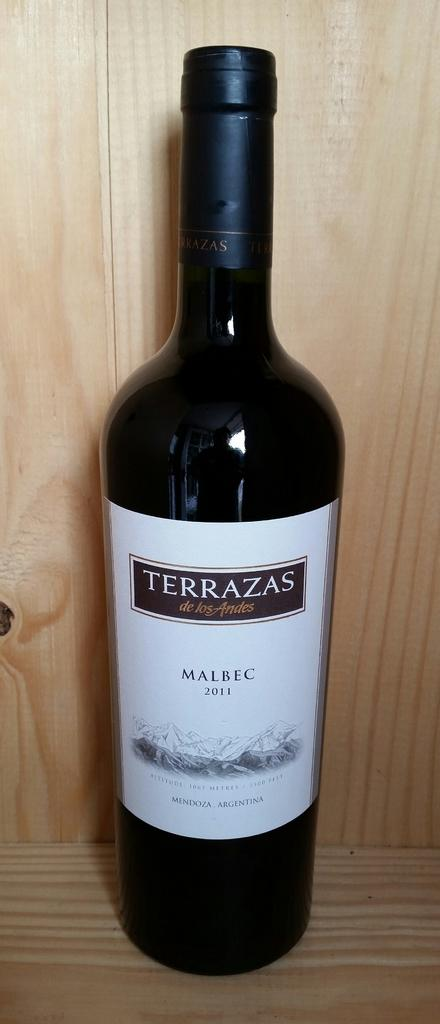<image>
Relay a brief, clear account of the picture shown. Terrazas' Malbec  compliments a meal of shrimp and lobster tail. 